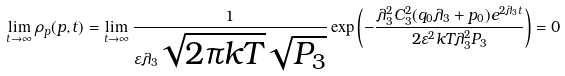Convert formula to latex. <formula><loc_0><loc_0><loc_500><loc_500>\lim _ { t \to \infty } \rho _ { p } ( p , t ) = \lim _ { t \to \infty } \frac { 1 } { \varepsilon \lambda _ { 3 } \sqrt { 2 \pi k T } \sqrt { P _ { 3 } } } \exp { \left ( - \frac { \lambda _ { 3 } ^ { 2 } C _ { 3 } ^ { 2 } ( q _ { 0 } \lambda _ { 3 } + p _ { 0 } ) e ^ { 2 \lambda _ { 3 } t } } { 2 \varepsilon ^ { 2 } k T \lambda _ { 3 } ^ { 2 } P _ { 3 } } \right ) } = 0</formula> 